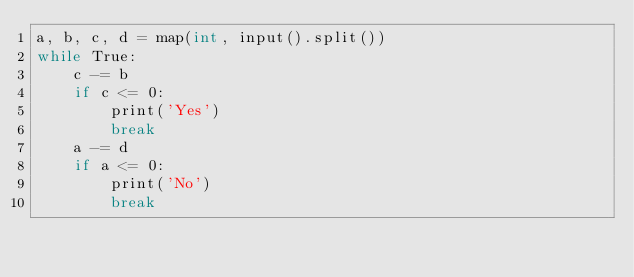Convert code to text. <code><loc_0><loc_0><loc_500><loc_500><_C_>a, b, c, d = map(int, input().split())
while True:
    c -= b
    if c <= 0:
        print('Yes')
        break
    a -= d
    if a <= 0:
        print('No')
        break</code> 